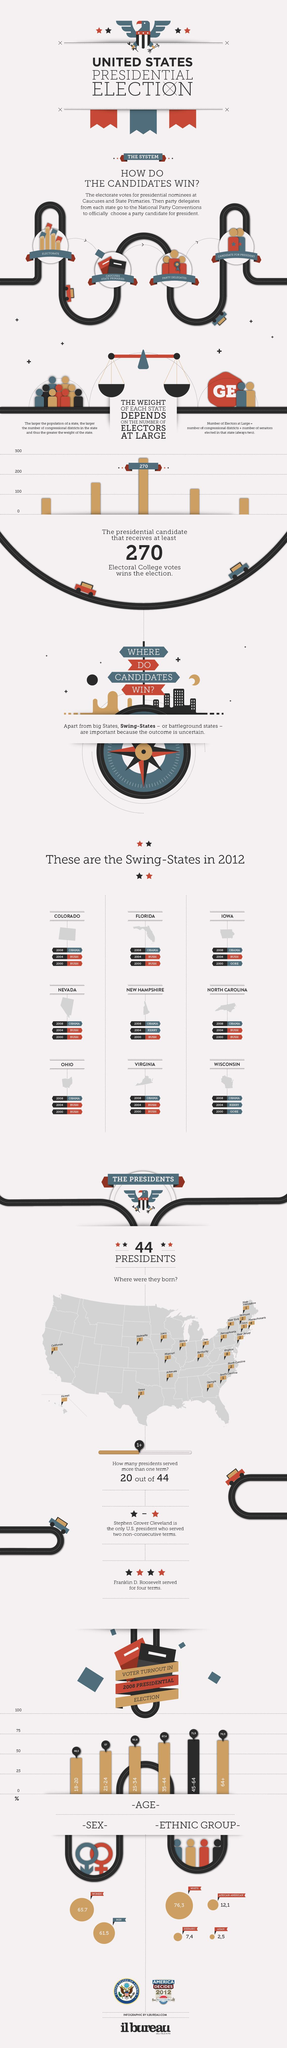what was the total voter turn out for age below 21
Answer the question with a short phrase. 48,5 where is the candidate for president chosen national party conventions which state was the birth state for the most number of presidents virginia which ethnic group had second highest turn out African-American Which sex had better turn out women how many swing states in 2012 9 Whom did Nevada support more bush 